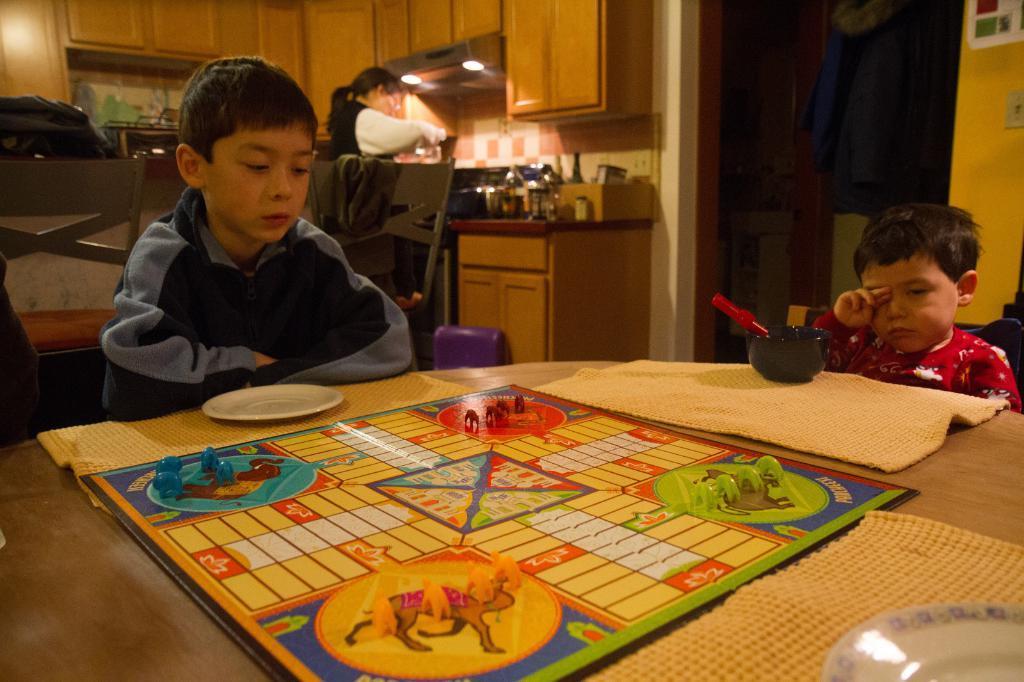How would you summarize this image in a sentence or two? In this image there are three persons. At the foreground of the image there are two kids sitting on the table and at the foreground of the image there is a game and at the background of the image there is a woman doing some work in kitchen. 